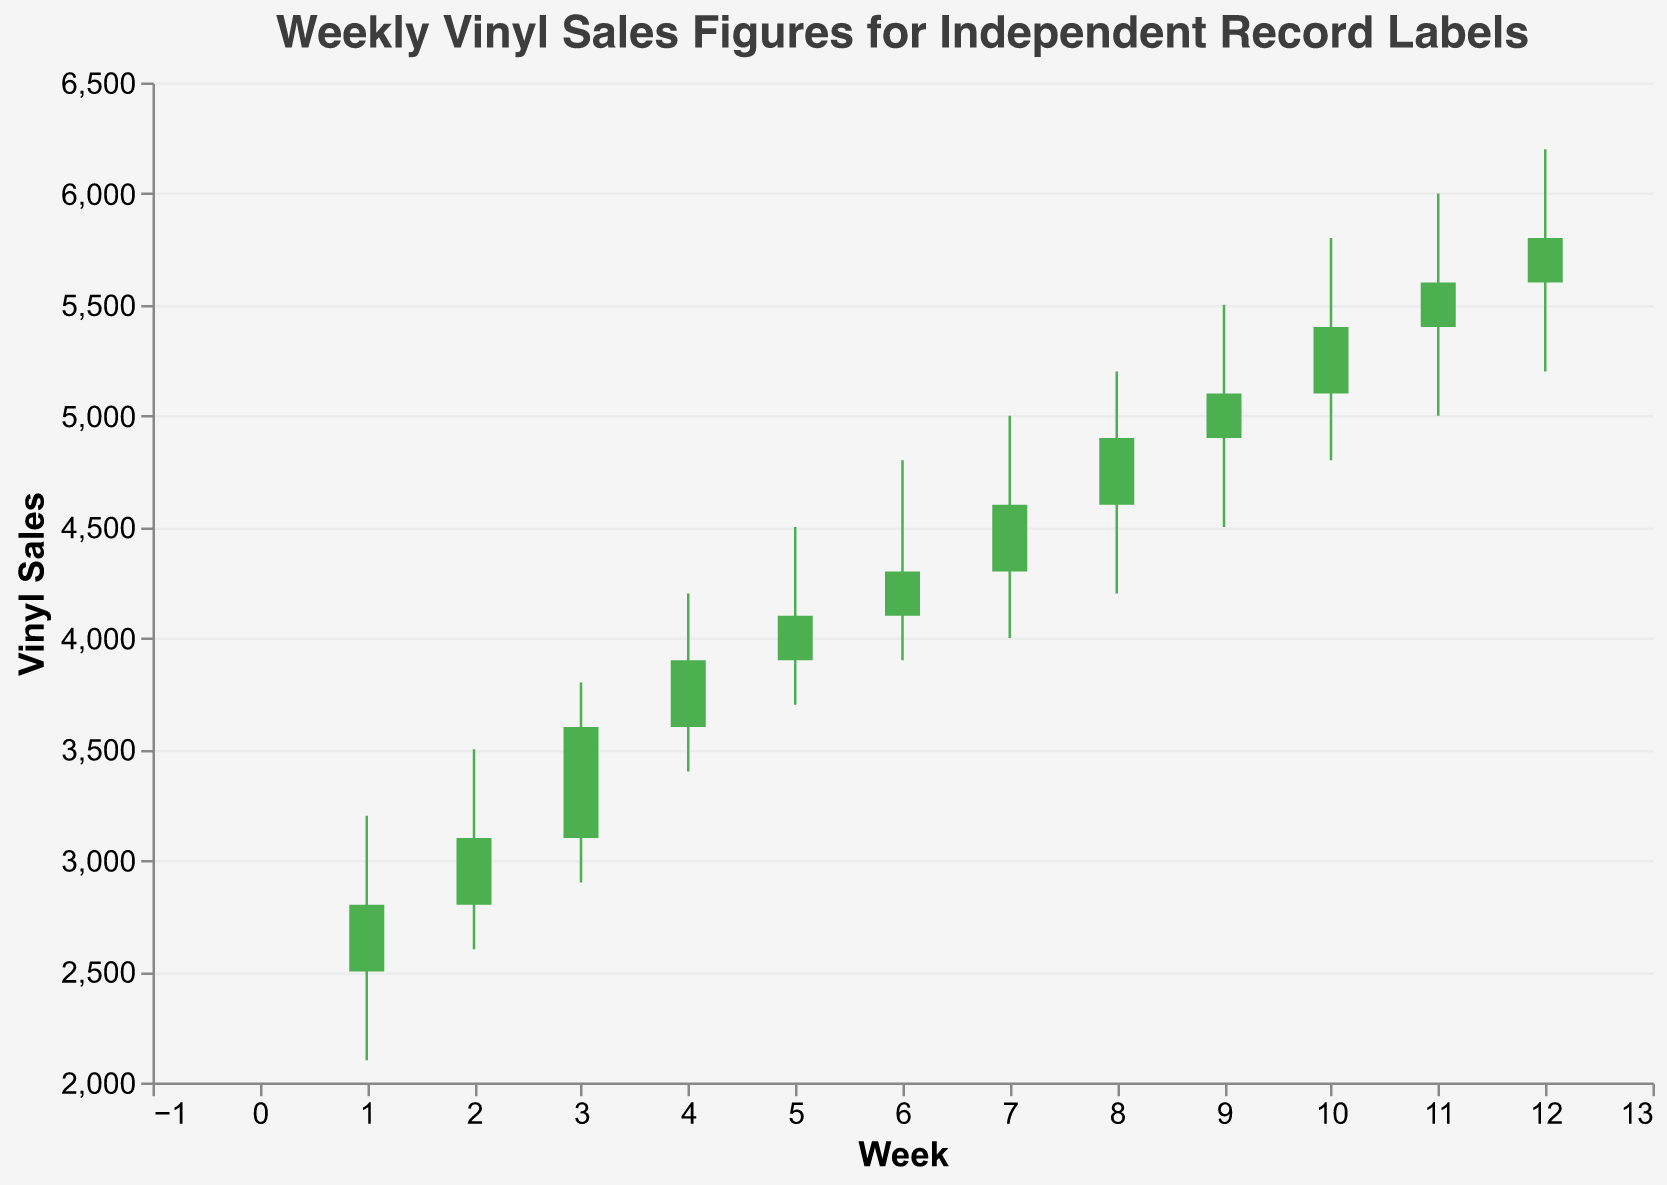What's the trend for Rough Trade's vinyl sales in Week 1? The OHLC chart shows that Rough Trade started at 2500, hit a high of 3200, dropped to a low of 2100, and closed at 2800. This indicates some fluctuation with a positive overall trend from the opening to the closing.
Answer: Positive trend from 2500 to 2800 What is the highest weekly vinyl sales figure recorded across all independent labels in the data? The highest figure in the 'High' field across the data is 6200, recorded by Drag City in Week 12.
Answer: 6200 Which week shows the smallest range between the High and Low figures? The week with the smallest range between High and Low is Week 11 (Saddle Creek), where the range is 1000 (6000 - 5000).
Answer: Week 11 Which label had the greatest increase from Open to Close in any given week? To determine this, we look for the label with the largest difference between Open and Close values. In Week 4, 4AD had a notable increase from 3600 to 3900, a difference of 300.
Answer: 4AD How do the vinyl sales of Merge Records in Week 2 compare to those of Domino in Week 5? Merge Records in Week 2 started at 2800 and closed at 3100, while Domino in Week 5 started at 3900 and closed at 4100. Domino consistently shows higher sales figures.
Answer: Domino is higher Which week shows the highest level of volatility? Volatility can be evaluated by the range between High and Low. Week 1 (Rough Trade) shows significant volatility, with a range of 1100 (3200 - 2100).
Answer: Week 1 Are there any weeks where the Close figure was lower than the Open figure? The color-coding in the chart aids in this; red bars indicate the Close was lower than the Open. By reviewing the chart, we can see that Week 1 is such an instance.
Answer: Yes, Week 1 How many independent labels are represented in the data? By counting the unique label names listed in the data, we find there are 12 independent labels.
Answer: 12 Between Secretly Canadian (Week 7) and Jagjaguwar (Week 8), which label had a better performance based on Close figures? Secretly Canadian closed at 4600, while Jagjaguwar closed at 4900. Jagjaguwar had the better closing figure.
Answer: Jagjaguwar 